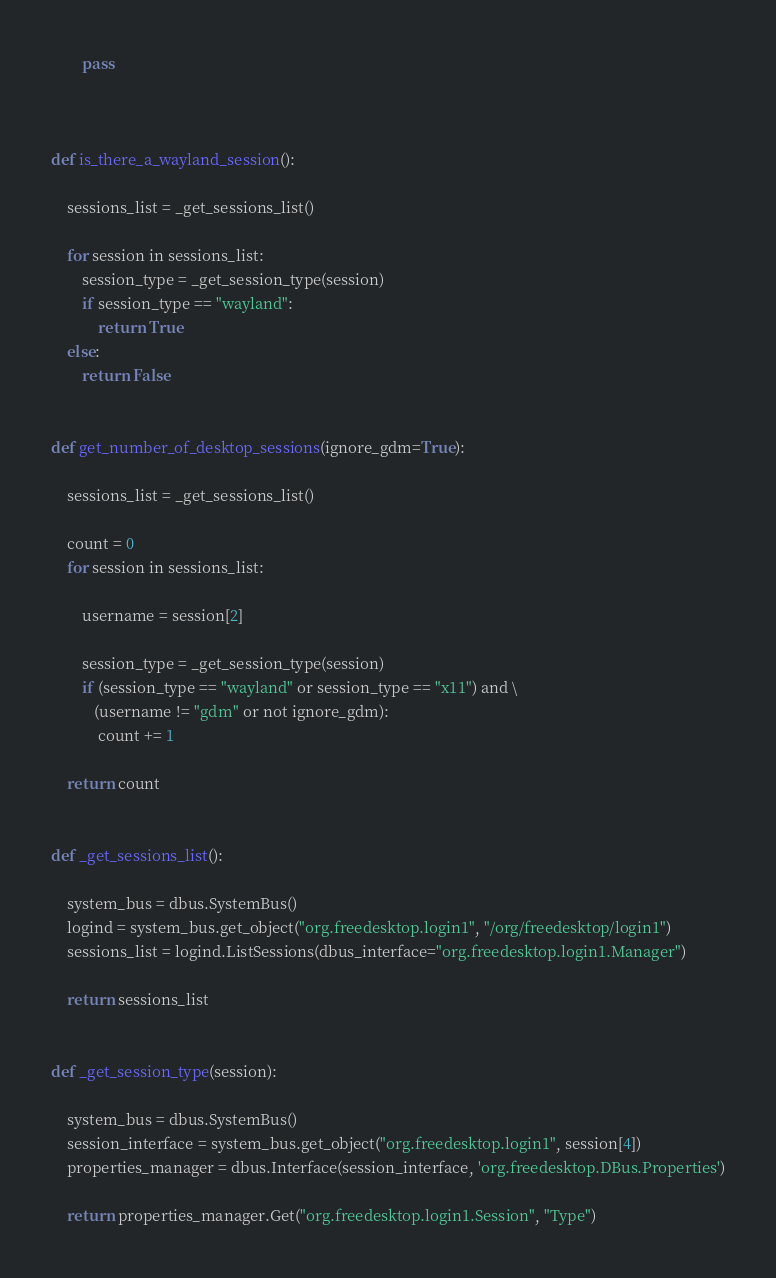Convert code to text. <code><loc_0><loc_0><loc_500><loc_500><_Python_>        pass



def is_there_a_wayland_session():

    sessions_list = _get_sessions_list()

    for session in sessions_list:
        session_type = _get_session_type(session)
        if session_type == "wayland":
            return True
    else:
        return False


def get_number_of_desktop_sessions(ignore_gdm=True):

    sessions_list = _get_sessions_list()

    count = 0
    for session in sessions_list:

        username = session[2]

        session_type = _get_session_type(session)
        if (session_type == "wayland" or session_type == "x11") and \
           (username != "gdm" or not ignore_gdm):
            count += 1

    return count


def _get_sessions_list():

    system_bus = dbus.SystemBus()
    logind = system_bus.get_object("org.freedesktop.login1", "/org/freedesktop/login1")
    sessions_list = logind.ListSessions(dbus_interface="org.freedesktop.login1.Manager")

    return sessions_list


def _get_session_type(session):

    system_bus = dbus.SystemBus()
    session_interface = system_bus.get_object("org.freedesktop.login1", session[4])
    properties_manager = dbus.Interface(session_interface, 'org.freedesktop.DBus.Properties')

    return properties_manager.Get("org.freedesktop.login1.Session", "Type")
</code> 